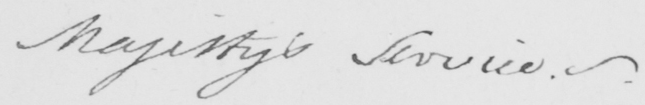What text is written in this handwritten line? Majesty ' s Service . _  . 